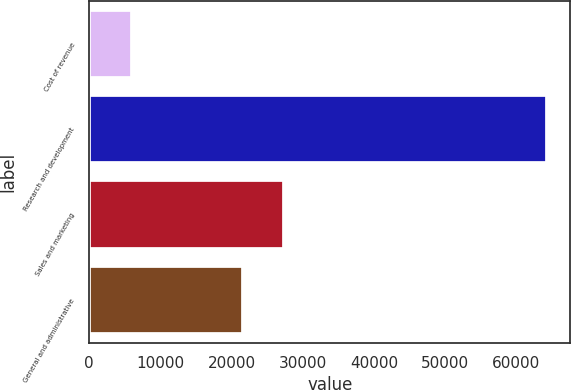Convert chart to OTSL. <chart><loc_0><loc_0><loc_500><loc_500><bar_chart><fcel>Cost of revenue<fcel>Research and development<fcel>Sales and marketing<fcel>General and administrative<nl><fcel>5952<fcel>64386<fcel>27413.4<fcel>21570<nl></chart> 